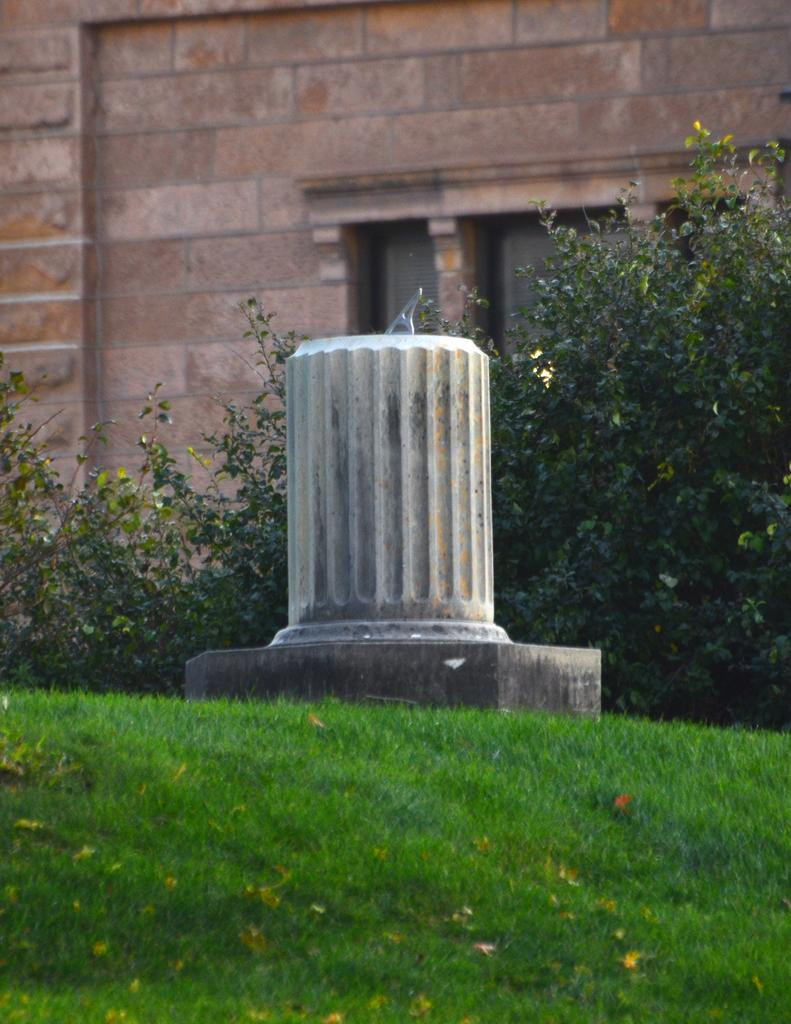What is the main subject in the center of the image? There is a statue in the center of the image. What can be seen in the background of the image? There are planets visible in the background, and there is also a building with windows. What type of oven is used to cook the planets in the image? There is no oven present in the image, and the planets are not being cooked. 